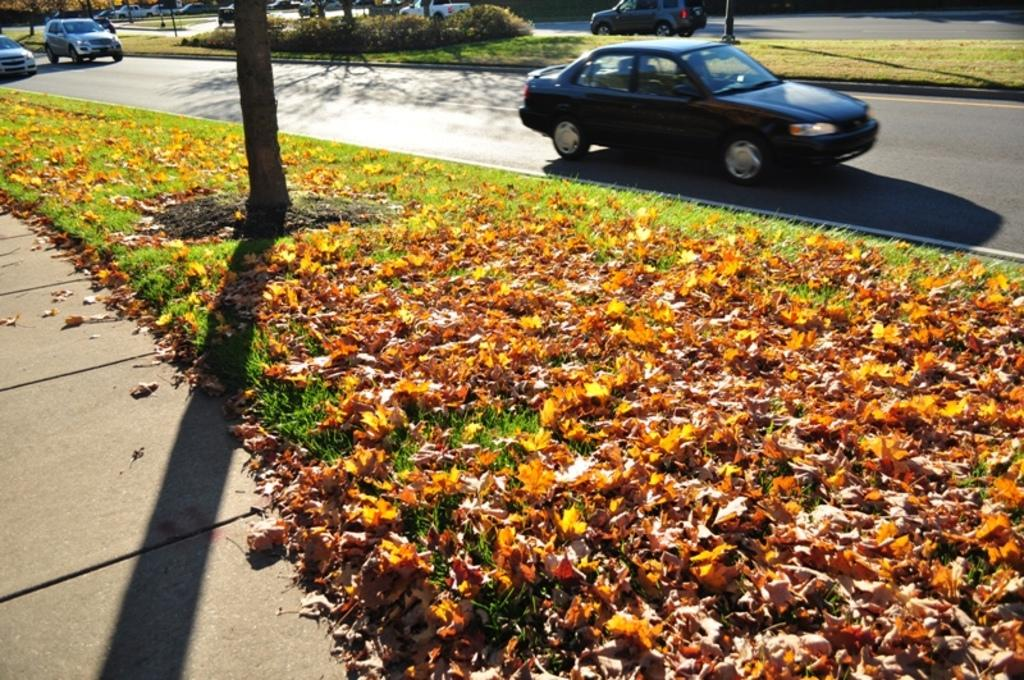What type of plants can be seen in the image? There are flowers in the image. What else can be seen in the image besides flowers? There is grass in the image. Where are the flowers and grass located? The flowers and grass are located on the side of a road. What else is visible in the image? Cars are visible on the road in the image. What is the price of the flowers in the image? The image does not provide information about the price of the flowers, as it only shows their appearance and location. 